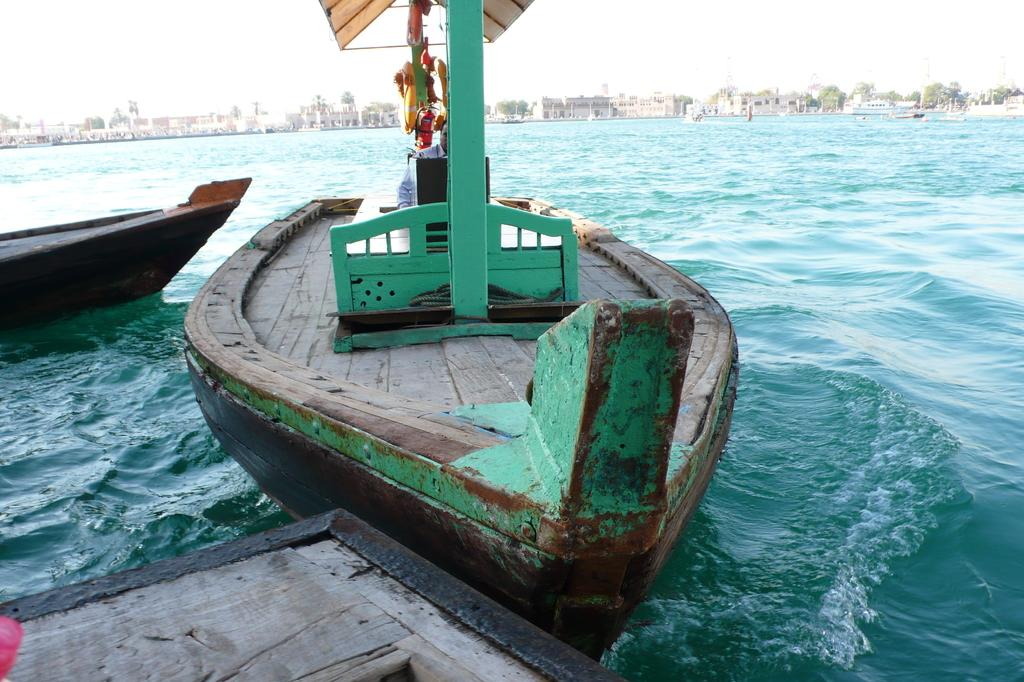What is the primary element in the image? There is water in the image. What is present in the water? There are boats in the water. Can you describe the person in the image? A man is sitting on one of the boats. What can be seen in the background of the image? There are buildings and trees in the background of the image. What type of plantation can be seen in the image? There is no plantation present in the image. Who is the partner of the man sitting on the boat? There is no partner mentioned or visible in the image. 